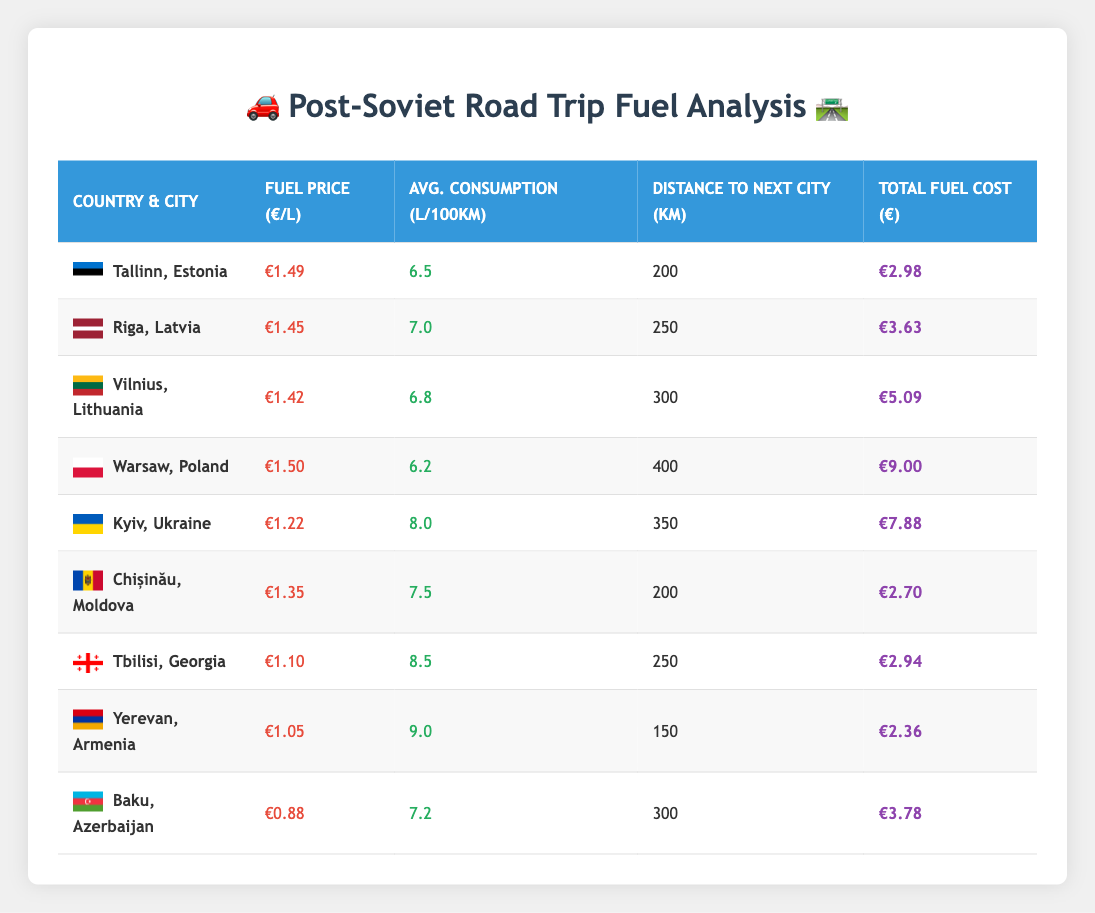What is the fuel price per liter in Azerbaijan? According to the table, the fuel price per liter in Azerbaijan (Baku) is €0.88.
Answer: €0.88 Which country has the highest average fuel consumption per 100 kilometers? The table shows that Armenia (Yerevan) has the highest average fuel consumption at 9.0 liters per 100 kilometers.
Answer: Armenia What is the total fuel cost for traveling from Kyiv to the next city? The total fuel cost for the distance from Kyiv (Ukraine) to the next city is given as €7.88.
Answer: €7.88 How much more expensive is fuel in Estonia compared to Georgia? The fuel price in Estonia is €1.49, while in Georgia, it is €1.10. The difference is calculated as €1.49 - €1.10 = €0.39.
Answer: €0.39 Is the total fuel cost for traveling from Warsaw greater than from Vilnius? The total fuel cost from Warsaw is €9.00 and from Vilnius is €5.09. Since €9.00 is greater than €5.09, the statement is true.
Answer: Yes What is the average fuel price across all listed countries? To find the average, we sum the fuel prices: (1.49 + 1.45 + 1.42 + 1.50 + 1.22 + 1.35 + 1.10 + 1.05 + 0.88) = 11.46. There are 9 countries, so the average is 11.46 / 9 ≈ 1.27.
Answer: €1.27 Which city has the lowest total fuel cost for the next trip? The table indicates that Yerevan, Armenia has the lowest total fuel cost at €2.36 for the next city.
Answer: Yerevan If I travel from Riga to Vilnius, how much will I spend on fuel? The distance from Riga to Vilnius is not given, but the total distance to the next listed city for Riga is 250 km with a total fuel cost of €3.63. Therefore, if traveling directly to Vilnius, expected cost is around €3.63.
Answer: €3.63 How many kilometers do I need to travel from Tallinn to reach the next city? The table shows that the distance to the next city from Tallinn (Estonia) is 200 kilometers.
Answer: 200 km 